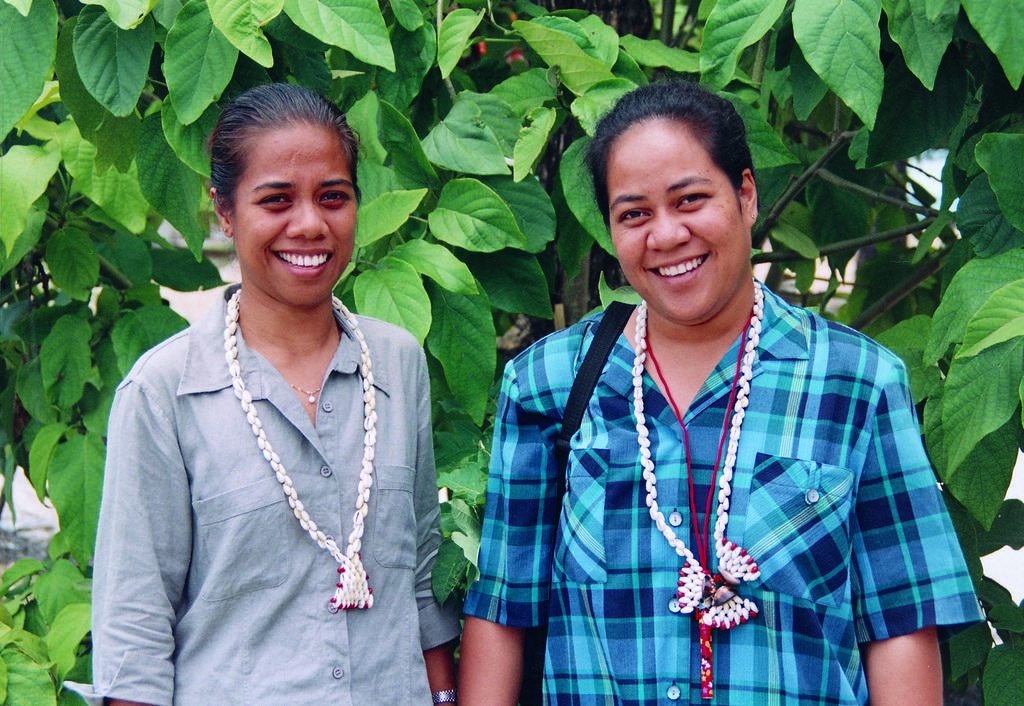How many people are present in the image? There are two people in the image. What expressions do the people have on their faces? The people are wearing smiles on their faces. What can be seen in the background of the image? There are trees visible in the background of the image. What type of pest can be seen crawling on the side of the person in the image? There is no pest visible in the image, and no one is shown crawling on the side of a person. 